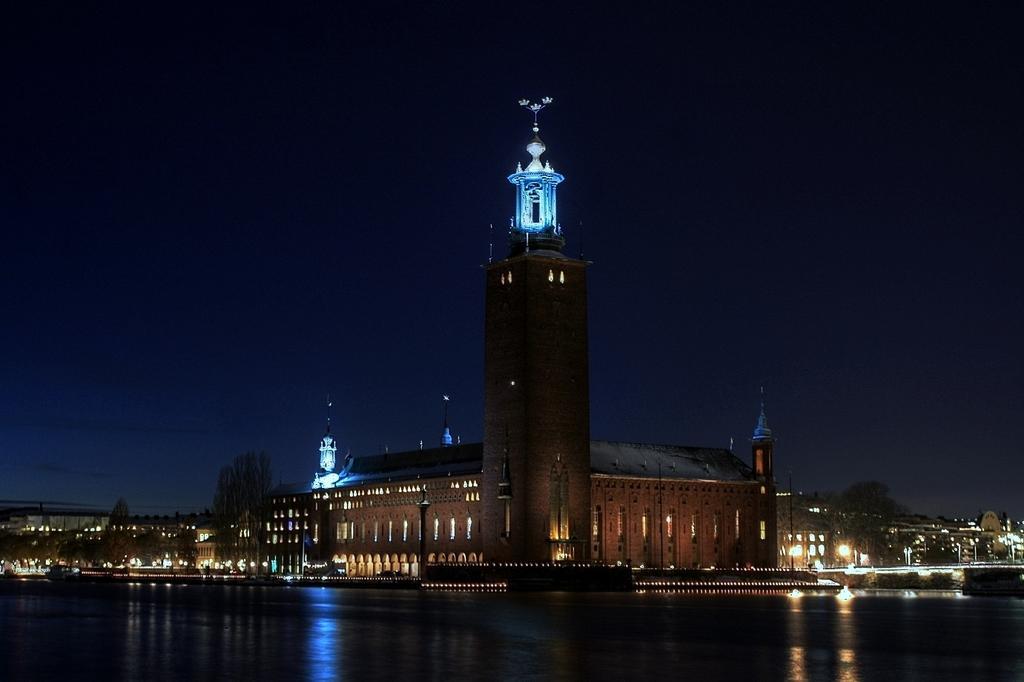Could you give a brief overview of what you see in this image? In the foreground of the picture there is a water body. In the center of the picture there are buildings, lights and trees. 